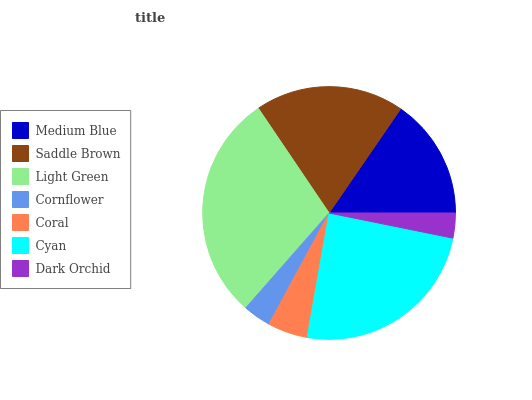Is Dark Orchid the minimum?
Answer yes or no. Yes. Is Light Green the maximum?
Answer yes or no. Yes. Is Saddle Brown the minimum?
Answer yes or no. No. Is Saddle Brown the maximum?
Answer yes or no. No. Is Saddle Brown greater than Medium Blue?
Answer yes or no. Yes. Is Medium Blue less than Saddle Brown?
Answer yes or no. Yes. Is Medium Blue greater than Saddle Brown?
Answer yes or no. No. Is Saddle Brown less than Medium Blue?
Answer yes or no. No. Is Medium Blue the high median?
Answer yes or no. Yes. Is Medium Blue the low median?
Answer yes or no. Yes. Is Saddle Brown the high median?
Answer yes or no. No. Is Light Green the low median?
Answer yes or no. No. 